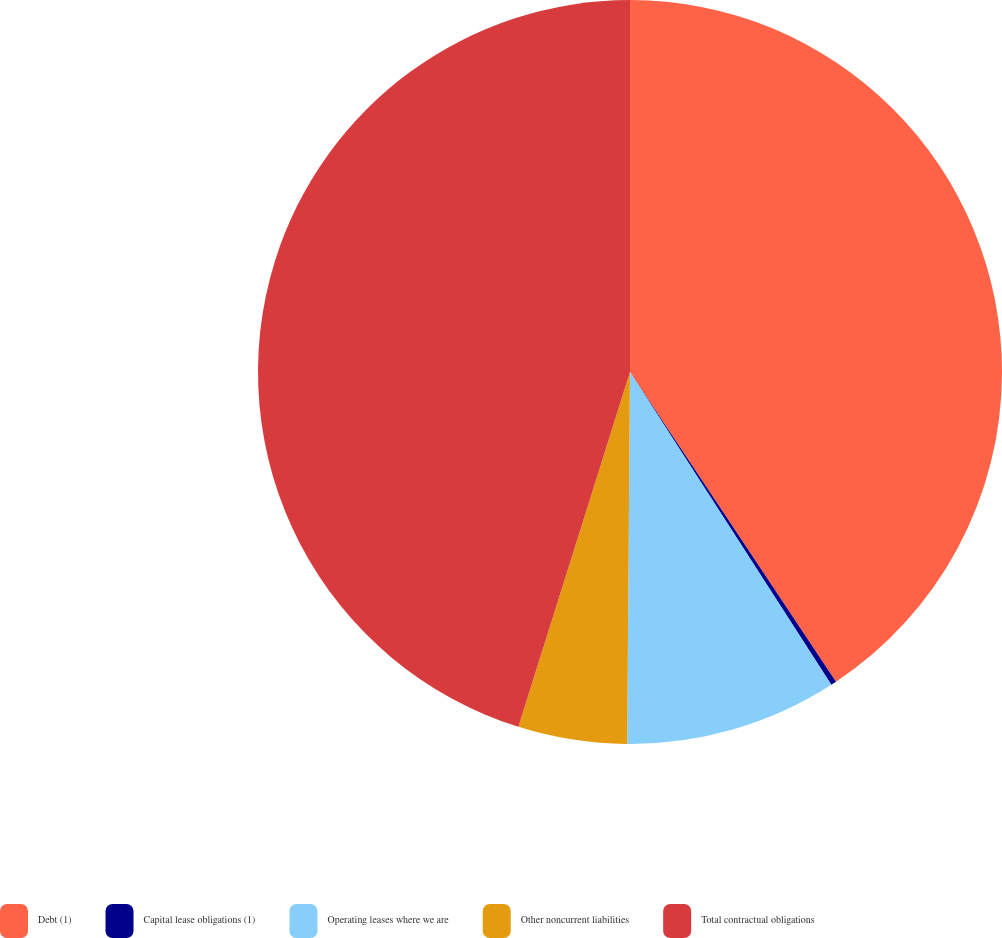<chart> <loc_0><loc_0><loc_500><loc_500><pie_chart><fcel>Debt (1)<fcel>Capital lease obligations (1)<fcel>Operating leases where we are<fcel>Other noncurrent liabilities<fcel>Total contractual obligations<nl><fcel>40.66%<fcel>0.24%<fcel>9.22%<fcel>4.73%<fcel>45.15%<nl></chart> 